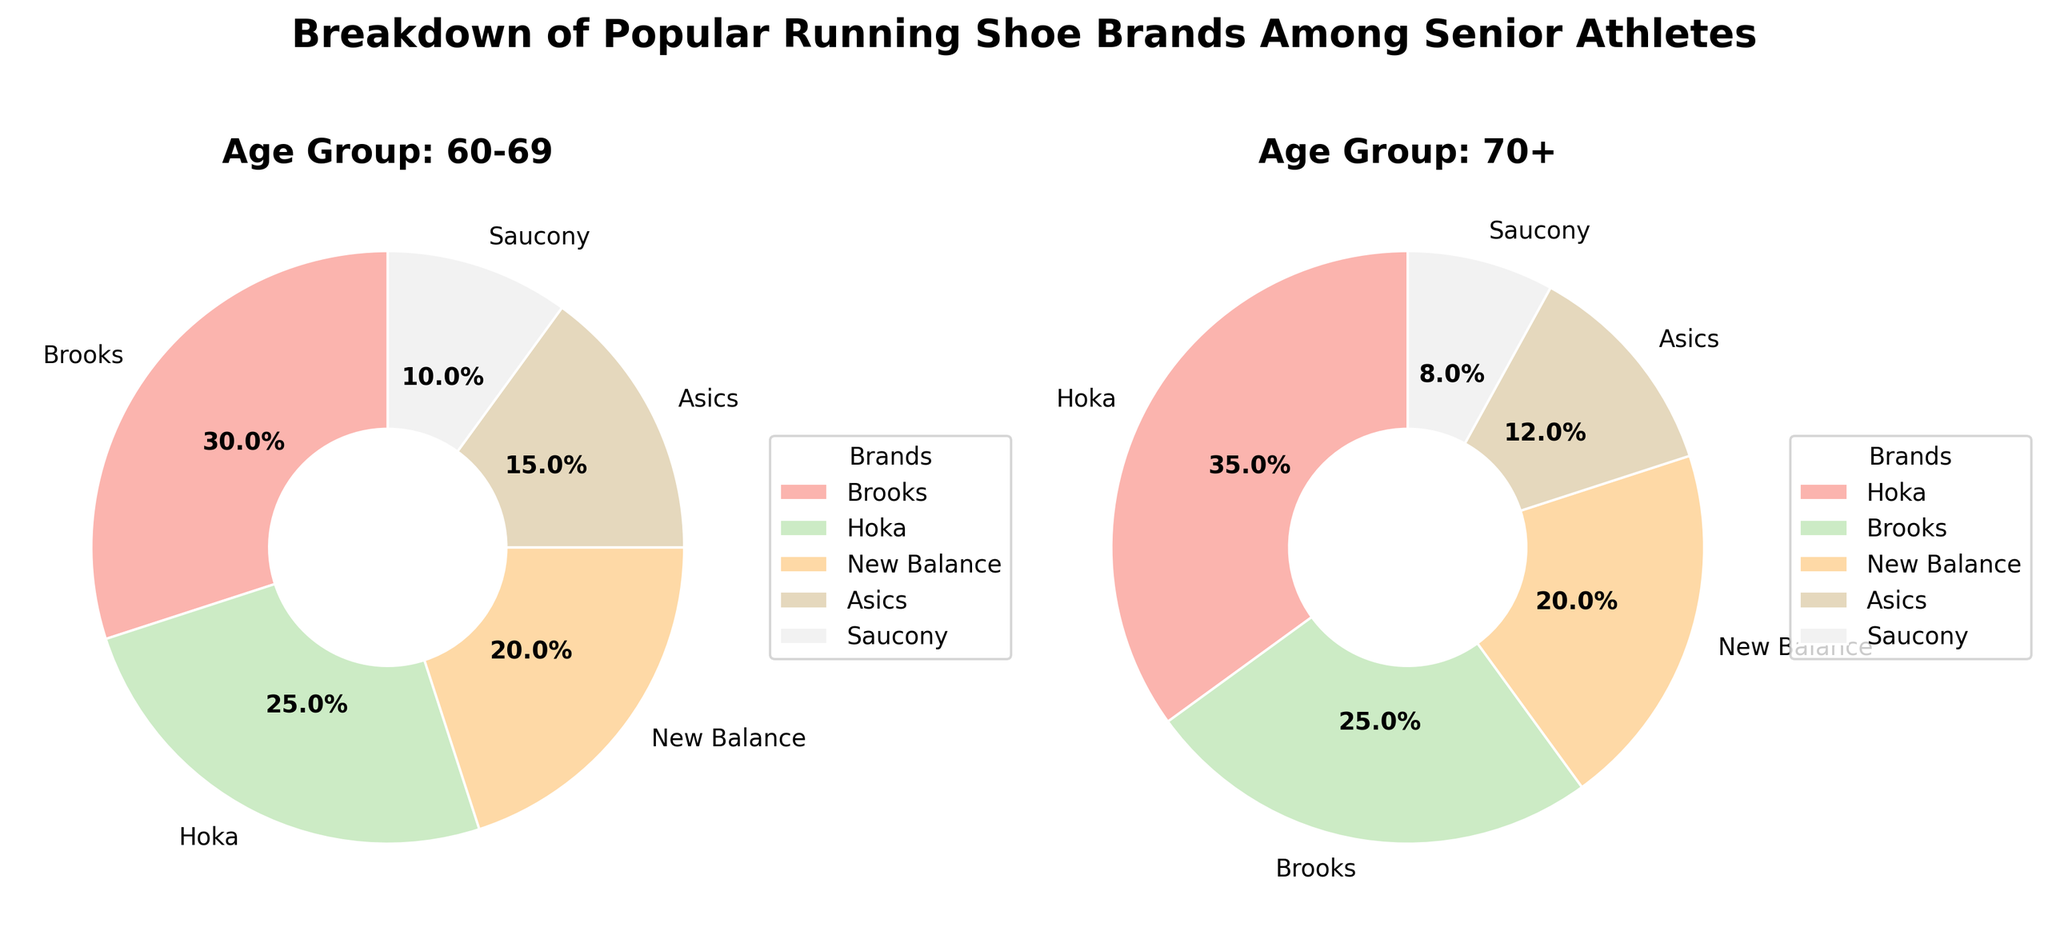What are the top two brands in the 70+ age group? Among the 70+ age group section of the pie chart, the two largest slices represent Hoka and Brooks, with 35% and 25% respectively.
Answer: Hoka and Brooks Which brand has the smallest percentage in the 60-69 age group? Observing the 60-69 age group pie chart, the smallest segment corresponds to Saucony, which makes up 10% of the chart.
Answer: Saucony What is the percentage difference between Hoka and New Balance in the 70+ age group? In the 70+ age group, Hoka holds 35% and New Balance has 20%. The difference between these percentages is calculated by subtracting 20 from 35.
Answer: 15% Which age group has a higher percentage of New Balance users? By comparing both pie charts, the 60-69 age group shows New Balance at 20%, while the same brand in the 70+ age group also holds 20%. Since the percentages are the same, neither age group has a higher percentage of New Balance users.
Answer: Both are equal What is the combined percentage of Brooks and Asics in the 60-69 age group? In the 60-69 age group of the pie chart, Brooks accounts for 30% and Asics makes up 15%. Adding these percentages together results in 45%.
Answer: 45% Which brand has a greater share among the 70+ age group compared to the 60-69 age group? Comparing both pie charts, Hoka has 25% in the 60-69 age group and 35% in the 70+ group, showing a greater share in the 70+ age group.
Answer: Hoka What is the total percentage occupied by Hoka across both age groups? The pie charts indicate that Hoka represents 25% in the 60-69 age group and 35% in the 70+ age group. Summing these percentages gives a total of 60%.
Answer: 60% Are there any brands that have the same percentage in both age groups? Reviewing both pie charts, New Balance consistently holds 20% in both the 60-69 and 70+ age groups.
Answer: New Balance 